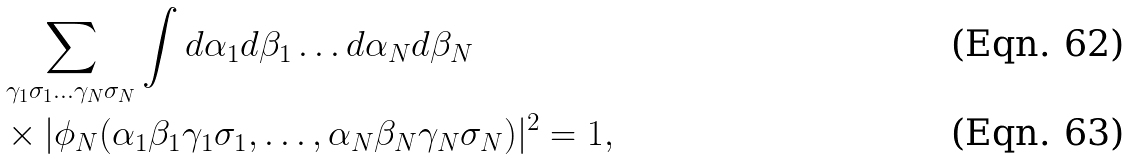Convert formula to latex. <formula><loc_0><loc_0><loc_500><loc_500>& \sum _ { \gamma _ { 1 } \sigma _ { 1 } \dots \gamma _ { N } \sigma _ { N } } \int d \alpha _ { 1 } d \beta _ { 1 } \dots d \alpha _ { N } d \beta _ { N } \\ & \times | \phi _ { N } ( \alpha _ { 1 } \beta _ { 1 } \gamma _ { 1 } \sigma _ { 1 } , \dots , \alpha _ { N } \beta _ { N } \gamma _ { N } \sigma _ { N } ) | ^ { 2 } = 1 ,</formula> 